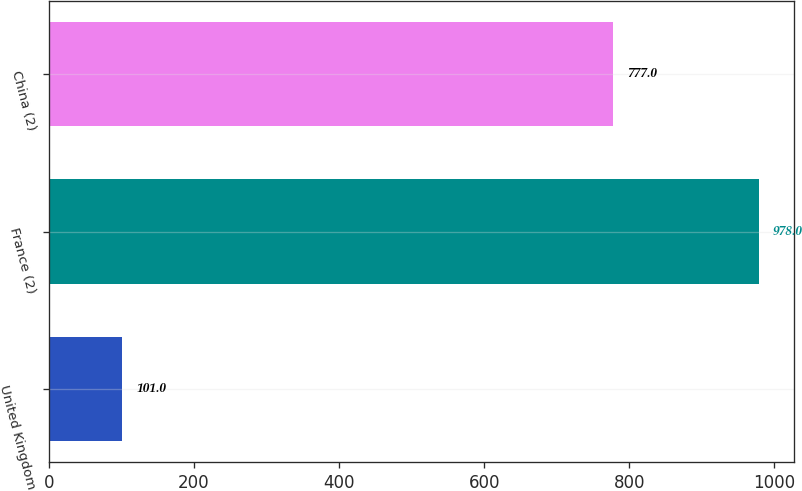<chart> <loc_0><loc_0><loc_500><loc_500><bar_chart><fcel>United Kingdom<fcel>France (2)<fcel>China (2)<nl><fcel>101<fcel>978<fcel>777<nl></chart> 